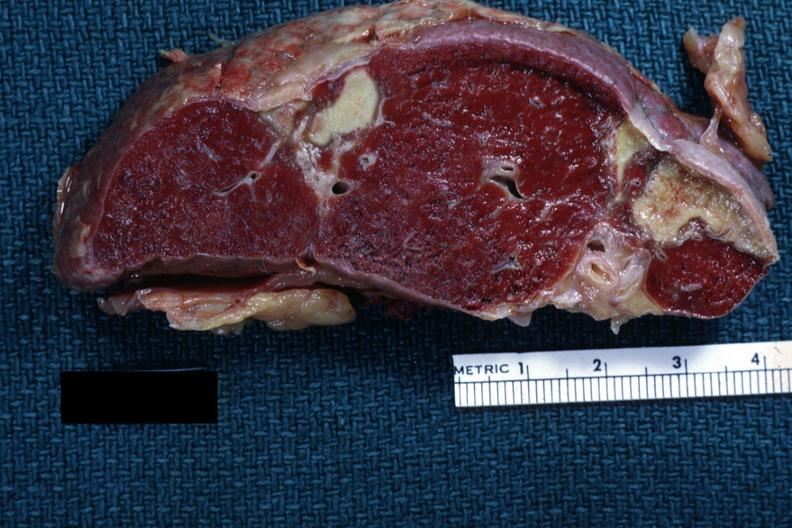does this image show excellentremote infarct with yellow centers?
Answer the question using a single word or phrase. Yes 